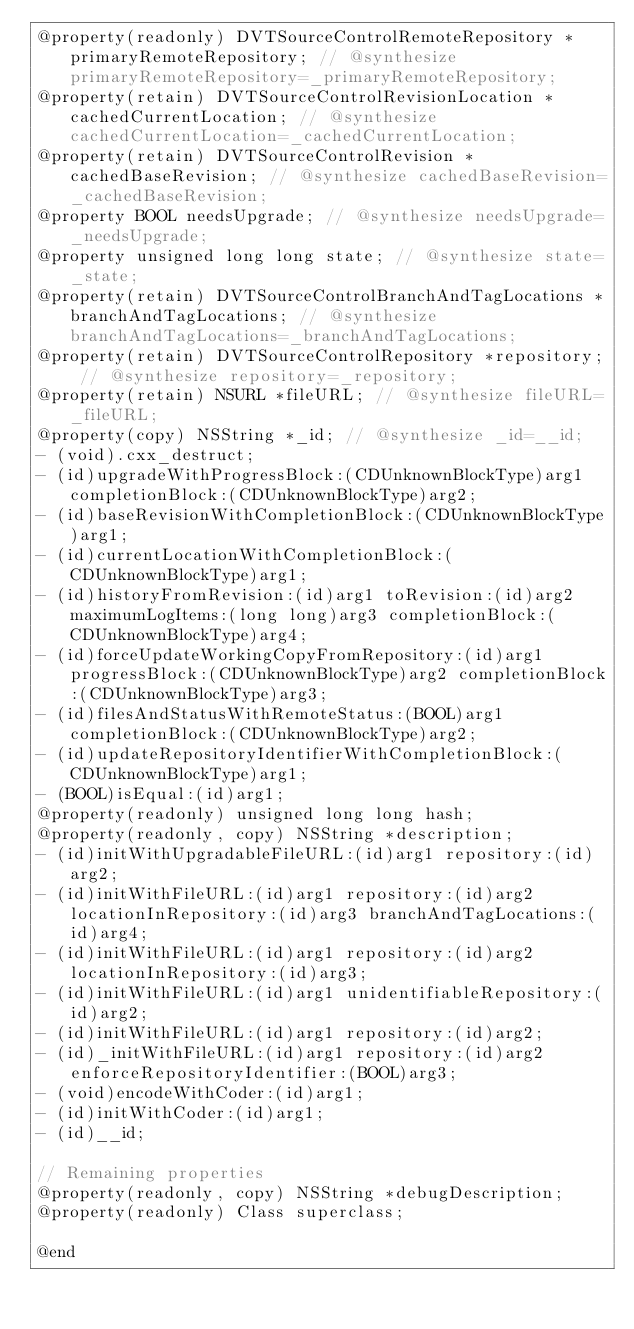<code> <loc_0><loc_0><loc_500><loc_500><_C_>@property(readonly) DVTSourceControlRemoteRepository *primaryRemoteRepository; // @synthesize primaryRemoteRepository=_primaryRemoteRepository;
@property(retain) DVTSourceControlRevisionLocation *cachedCurrentLocation; // @synthesize cachedCurrentLocation=_cachedCurrentLocation;
@property(retain) DVTSourceControlRevision *cachedBaseRevision; // @synthesize cachedBaseRevision=_cachedBaseRevision;
@property BOOL needsUpgrade; // @synthesize needsUpgrade=_needsUpgrade;
@property unsigned long long state; // @synthesize state=_state;
@property(retain) DVTSourceControlBranchAndTagLocations *branchAndTagLocations; // @synthesize branchAndTagLocations=_branchAndTagLocations;
@property(retain) DVTSourceControlRepository *repository; // @synthesize repository=_repository;
@property(retain) NSURL *fileURL; // @synthesize fileURL=_fileURL;
@property(copy) NSString *_id; // @synthesize _id=__id;
- (void).cxx_destruct;
- (id)upgradeWithProgressBlock:(CDUnknownBlockType)arg1 completionBlock:(CDUnknownBlockType)arg2;
- (id)baseRevisionWithCompletionBlock:(CDUnknownBlockType)arg1;
- (id)currentLocationWithCompletionBlock:(CDUnknownBlockType)arg1;
- (id)historyFromRevision:(id)arg1 toRevision:(id)arg2 maximumLogItems:(long long)arg3 completionBlock:(CDUnknownBlockType)arg4;
- (id)forceUpdateWorkingCopyFromRepository:(id)arg1 progressBlock:(CDUnknownBlockType)arg2 completionBlock:(CDUnknownBlockType)arg3;
- (id)filesAndStatusWithRemoteStatus:(BOOL)arg1 completionBlock:(CDUnknownBlockType)arg2;
- (id)updateRepositoryIdentifierWithCompletionBlock:(CDUnknownBlockType)arg1;
- (BOOL)isEqual:(id)arg1;
@property(readonly) unsigned long long hash;
@property(readonly, copy) NSString *description;
- (id)initWithUpgradableFileURL:(id)arg1 repository:(id)arg2;
- (id)initWithFileURL:(id)arg1 repository:(id)arg2 locationInRepository:(id)arg3 branchAndTagLocations:(id)arg4;
- (id)initWithFileURL:(id)arg1 repository:(id)arg2 locationInRepository:(id)arg3;
- (id)initWithFileURL:(id)arg1 unidentifiableRepository:(id)arg2;
- (id)initWithFileURL:(id)arg1 repository:(id)arg2;
- (id)_initWithFileURL:(id)arg1 repository:(id)arg2 enforceRepositoryIdentifier:(BOOL)arg3;
- (void)encodeWithCoder:(id)arg1;
- (id)initWithCoder:(id)arg1;
- (id)__id;

// Remaining properties
@property(readonly, copy) NSString *debugDescription;
@property(readonly) Class superclass;

@end

</code> 